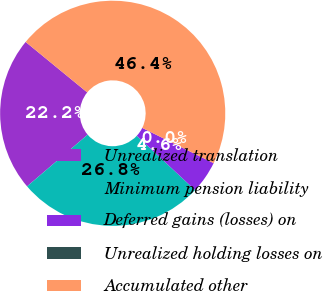Convert chart to OTSL. <chart><loc_0><loc_0><loc_500><loc_500><pie_chart><fcel>Unrealized translation<fcel>Minimum pension liability<fcel>Deferred gains (losses) on<fcel>Unrealized holding losses on<fcel>Accumulated other<nl><fcel>22.17%<fcel>26.81%<fcel>4.64%<fcel>0.0%<fcel>46.38%<nl></chart> 